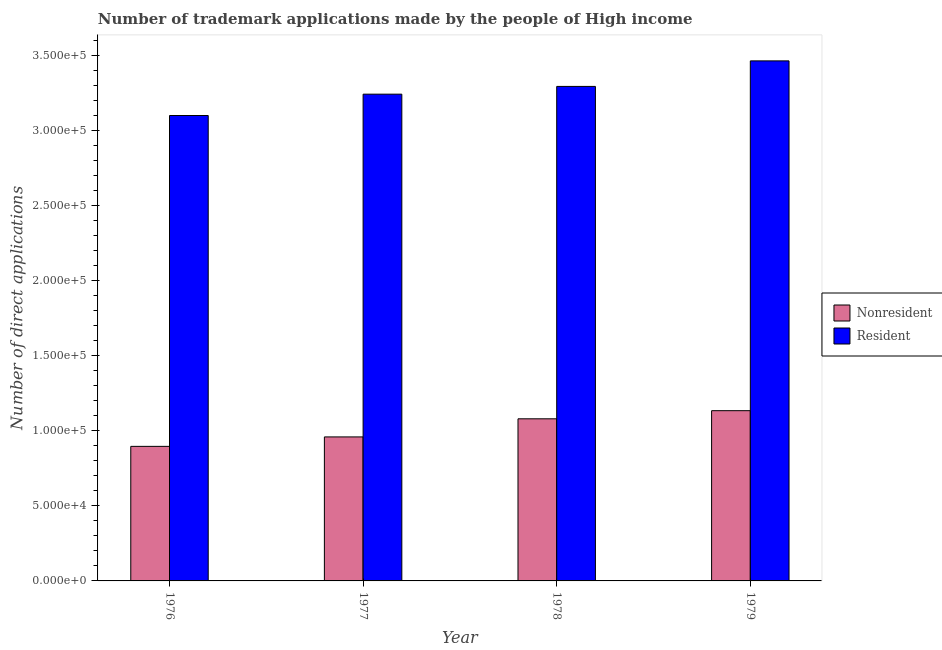How many groups of bars are there?
Provide a short and direct response. 4. Are the number of bars per tick equal to the number of legend labels?
Keep it short and to the point. Yes. Are the number of bars on each tick of the X-axis equal?
Ensure brevity in your answer.  Yes. How many bars are there on the 3rd tick from the left?
Make the answer very short. 2. How many bars are there on the 3rd tick from the right?
Provide a short and direct response. 2. What is the label of the 4th group of bars from the left?
Keep it short and to the point. 1979. In how many cases, is the number of bars for a given year not equal to the number of legend labels?
Give a very brief answer. 0. What is the number of trademark applications made by residents in 1976?
Provide a short and direct response. 3.10e+05. Across all years, what is the maximum number of trademark applications made by non residents?
Your response must be concise. 1.13e+05. Across all years, what is the minimum number of trademark applications made by residents?
Your response must be concise. 3.10e+05. In which year was the number of trademark applications made by non residents maximum?
Offer a very short reply. 1979. In which year was the number of trademark applications made by residents minimum?
Provide a short and direct response. 1976. What is the total number of trademark applications made by residents in the graph?
Your answer should be very brief. 1.31e+06. What is the difference between the number of trademark applications made by residents in 1976 and that in 1978?
Offer a terse response. -1.94e+04. What is the difference between the number of trademark applications made by non residents in 1979 and the number of trademark applications made by residents in 1978?
Your answer should be compact. 5417. What is the average number of trademark applications made by non residents per year?
Give a very brief answer. 1.02e+05. In how many years, is the number of trademark applications made by non residents greater than 200000?
Offer a very short reply. 0. What is the ratio of the number of trademark applications made by residents in 1977 to that in 1978?
Offer a very short reply. 0.98. Is the number of trademark applications made by residents in 1977 less than that in 1978?
Give a very brief answer. Yes. What is the difference between the highest and the second highest number of trademark applications made by residents?
Make the answer very short. 1.70e+04. What is the difference between the highest and the lowest number of trademark applications made by residents?
Make the answer very short. 3.64e+04. Is the sum of the number of trademark applications made by non residents in 1977 and 1978 greater than the maximum number of trademark applications made by residents across all years?
Make the answer very short. Yes. What does the 2nd bar from the left in 1978 represents?
Your answer should be very brief. Resident. What does the 2nd bar from the right in 1979 represents?
Ensure brevity in your answer.  Nonresident. Does the graph contain any zero values?
Your answer should be compact. No. What is the title of the graph?
Provide a succinct answer. Number of trademark applications made by the people of High income. Does "Primary school" appear as one of the legend labels in the graph?
Keep it short and to the point. No. What is the label or title of the Y-axis?
Make the answer very short. Number of direct applications. What is the Number of direct applications of Nonresident in 1976?
Your response must be concise. 8.96e+04. What is the Number of direct applications of Resident in 1976?
Ensure brevity in your answer.  3.10e+05. What is the Number of direct applications of Nonresident in 1977?
Your answer should be very brief. 9.59e+04. What is the Number of direct applications in Resident in 1977?
Your answer should be very brief. 3.24e+05. What is the Number of direct applications of Nonresident in 1978?
Offer a terse response. 1.08e+05. What is the Number of direct applications of Resident in 1978?
Ensure brevity in your answer.  3.29e+05. What is the Number of direct applications in Nonresident in 1979?
Keep it short and to the point. 1.13e+05. What is the Number of direct applications of Resident in 1979?
Your response must be concise. 3.46e+05. Across all years, what is the maximum Number of direct applications in Nonresident?
Give a very brief answer. 1.13e+05. Across all years, what is the maximum Number of direct applications of Resident?
Your answer should be compact. 3.46e+05. Across all years, what is the minimum Number of direct applications in Nonresident?
Keep it short and to the point. 8.96e+04. Across all years, what is the minimum Number of direct applications in Resident?
Provide a succinct answer. 3.10e+05. What is the total Number of direct applications in Nonresident in the graph?
Keep it short and to the point. 4.07e+05. What is the total Number of direct applications in Resident in the graph?
Ensure brevity in your answer.  1.31e+06. What is the difference between the Number of direct applications of Nonresident in 1976 and that in 1977?
Offer a very short reply. -6294. What is the difference between the Number of direct applications of Resident in 1976 and that in 1977?
Offer a terse response. -1.42e+04. What is the difference between the Number of direct applications of Nonresident in 1976 and that in 1978?
Offer a terse response. -1.84e+04. What is the difference between the Number of direct applications of Resident in 1976 and that in 1978?
Keep it short and to the point. -1.94e+04. What is the difference between the Number of direct applications in Nonresident in 1976 and that in 1979?
Offer a very short reply. -2.38e+04. What is the difference between the Number of direct applications in Resident in 1976 and that in 1979?
Your answer should be very brief. -3.64e+04. What is the difference between the Number of direct applications in Nonresident in 1977 and that in 1978?
Offer a terse response. -1.21e+04. What is the difference between the Number of direct applications of Resident in 1977 and that in 1978?
Ensure brevity in your answer.  -5166. What is the difference between the Number of direct applications of Nonresident in 1977 and that in 1979?
Your response must be concise. -1.75e+04. What is the difference between the Number of direct applications in Resident in 1977 and that in 1979?
Make the answer very short. -2.22e+04. What is the difference between the Number of direct applications in Nonresident in 1978 and that in 1979?
Ensure brevity in your answer.  -5417. What is the difference between the Number of direct applications of Resident in 1978 and that in 1979?
Ensure brevity in your answer.  -1.70e+04. What is the difference between the Number of direct applications of Nonresident in 1976 and the Number of direct applications of Resident in 1977?
Offer a terse response. -2.35e+05. What is the difference between the Number of direct applications in Nonresident in 1976 and the Number of direct applications in Resident in 1978?
Offer a very short reply. -2.40e+05. What is the difference between the Number of direct applications of Nonresident in 1976 and the Number of direct applications of Resident in 1979?
Your answer should be very brief. -2.57e+05. What is the difference between the Number of direct applications of Nonresident in 1977 and the Number of direct applications of Resident in 1978?
Make the answer very short. -2.34e+05. What is the difference between the Number of direct applications in Nonresident in 1977 and the Number of direct applications in Resident in 1979?
Your response must be concise. -2.51e+05. What is the difference between the Number of direct applications of Nonresident in 1978 and the Number of direct applications of Resident in 1979?
Offer a terse response. -2.38e+05. What is the average Number of direct applications in Nonresident per year?
Provide a short and direct response. 1.02e+05. What is the average Number of direct applications of Resident per year?
Give a very brief answer. 3.28e+05. In the year 1976, what is the difference between the Number of direct applications of Nonresident and Number of direct applications of Resident?
Give a very brief answer. -2.20e+05. In the year 1977, what is the difference between the Number of direct applications in Nonresident and Number of direct applications in Resident?
Offer a very short reply. -2.28e+05. In the year 1978, what is the difference between the Number of direct applications of Nonresident and Number of direct applications of Resident?
Offer a very short reply. -2.21e+05. In the year 1979, what is the difference between the Number of direct applications of Nonresident and Number of direct applications of Resident?
Keep it short and to the point. -2.33e+05. What is the ratio of the Number of direct applications of Nonresident in 1976 to that in 1977?
Provide a short and direct response. 0.93. What is the ratio of the Number of direct applications in Resident in 1976 to that in 1977?
Your response must be concise. 0.96. What is the ratio of the Number of direct applications of Nonresident in 1976 to that in 1978?
Make the answer very short. 0.83. What is the ratio of the Number of direct applications in Resident in 1976 to that in 1978?
Provide a succinct answer. 0.94. What is the ratio of the Number of direct applications in Nonresident in 1976 to that in 1979?
Keep it short and to the point. 0.79. What is the ratio of the Number of direct applications of Resident in 1976 to that in 1979?
Offer a terse response. 0.89. What is the ratio of the Number of direct applications in Nonresident in 1977 to that in 1978?
Ensure brevity in your answer.  0.89. What is the ratio of the Number of direct applications in Resident in 1977 to that in 1978?
Ensure brevity in your answer.  0.98. What is the ratio of the Number of direct applications of Nonresident in 1977 to that in 1979?
Your answer should be compact. 0.85. What is the ratio of the Number of direct applications of Resident in 1977 to that in 1979?
Give a very brief answer. 0.94. What is the ratio of the Number of direct applications of Nonresident in 1978 to that in 1979?
Give a very brief answer. 0.95. What is the ratio of the Number of direct applications in Resident in 1978 to that in 1979?
Your response must be concise. 0.95. What is the difference between the highest and the second highest Number of direct applications in Nonresident?
Give a very brief answer. 5417. What is the difference between the highest and the second highest Number of direct applications in Resident?
Your response must be concise. 1.70e+04. What is the difference between the highest and the lowest Number of direct applications in Nonresident?
Provide a succinct answer. 2.38e+04. What is the difference between the highest and the lowest Number of direct applications of Resident?
Your answer should be very brief. 3.64e+04. 